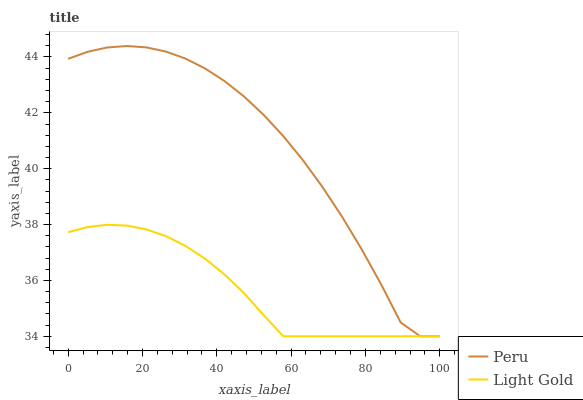Does Light Gold have the minimum area under the curve?
Answer yes or no. Yes. Does Peru have the maximum area under the curve?
Answer yes or no. Yes. Does Peru have the minimum area under the curve?
Answer yes or no. No. Is Light Gold the smoothest?
Answer yes or no. Yes. Is Peru the roughest?
Answer yes or no. Yes. Is Peru the smoothest?
Answer yes or no. No. Does Peru have the highest value?
Answer yes or no. Yes. Does Peru intersect Light Gold?
Answer yes or no. Yes. Is Peru less than Light Gold?
Answer yes or no. No. Is Peru greater than Light Gold?
Answer yes or no. No. 